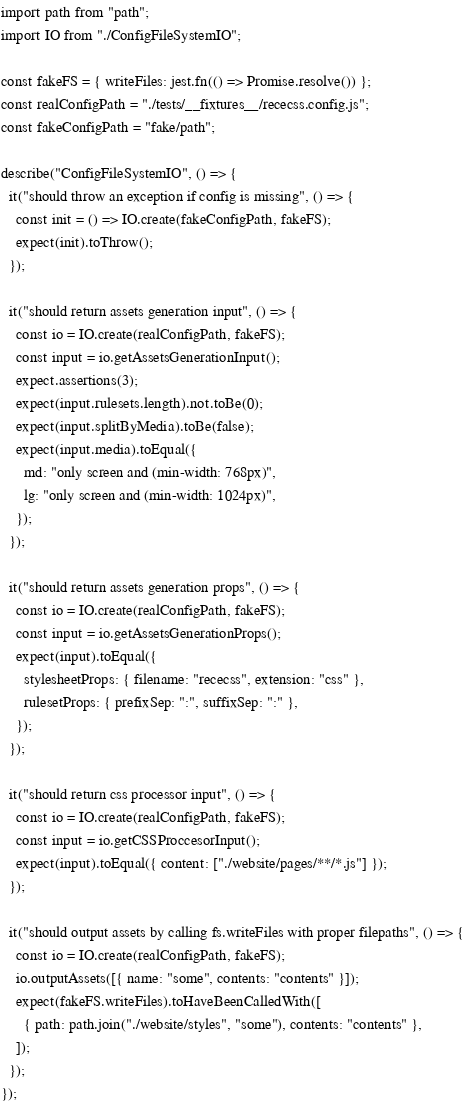<code> <loc_0><loc_0><loc_500><loc_500><_TypeScript_>import path from "path";
import IO from "./ConfigFileSystemIO";

const fakeFS = { writeFiles: jest.fn(() => Promise.resolve()) };
const realConfigPath = "./tests/__fixtures__/rececss.config.js";
const fakeConfigPath = "fake/path";

describe("ConfigFileSystemIO", () => {
  it("should throw an exception if config is missing", () => {
    const init = () => IO.create(fakeConfigPath, fakeFS);
    expect(init).toThrow();
  });

  it("should return assets generation input", () => {
    const io = IO.create(realConfigPath, fakeFS);
    const input = io.getAssetsGenerationInput();
    expect.assertions(3);
    expect(input.rulesets.length).not.toBe(0);
    expect(input.splitByMedia).toBe(false);
    expect(input.media).toEqual({
      md: "only screen and (min-width: 768px)",
      lg: "only screen and (min-width: 1024px)",
    });
  });

  it("should return assets generation props", () => {
    const io = IO.create(realConfigPath, fakeFS);
    const input = io.getAssetsGenerationProps();
    expect(input).toEqual({
      stylesheetProps: { filename: "rececss", extension: "css" },
      rulesetProps: { prefixSep: ":", suffixSep: ":" },
    });
  });

  it("should return css processor input", () => {
    const io = IO.create(realConfigPath, fakeFS);
    const input = io.getCSSProccesorInput();
    expect(input).toEqual({ content: ["./website/pages/**/*.js"] });
  });

  it("should output assets by calling fs.writeFiles with proper filepaths", () => {
    const io = IO.create(realConfigPath, fakeFS);
    io.outputAssets([{ name: "some", contents: "contents" }]);
    expect(fakeFS.writeFiles).toHaveBeenCalledWith([
      { path: path.join("./website/styles", "some"), contents: "contents" },
    ]);
  });
});
</code> 